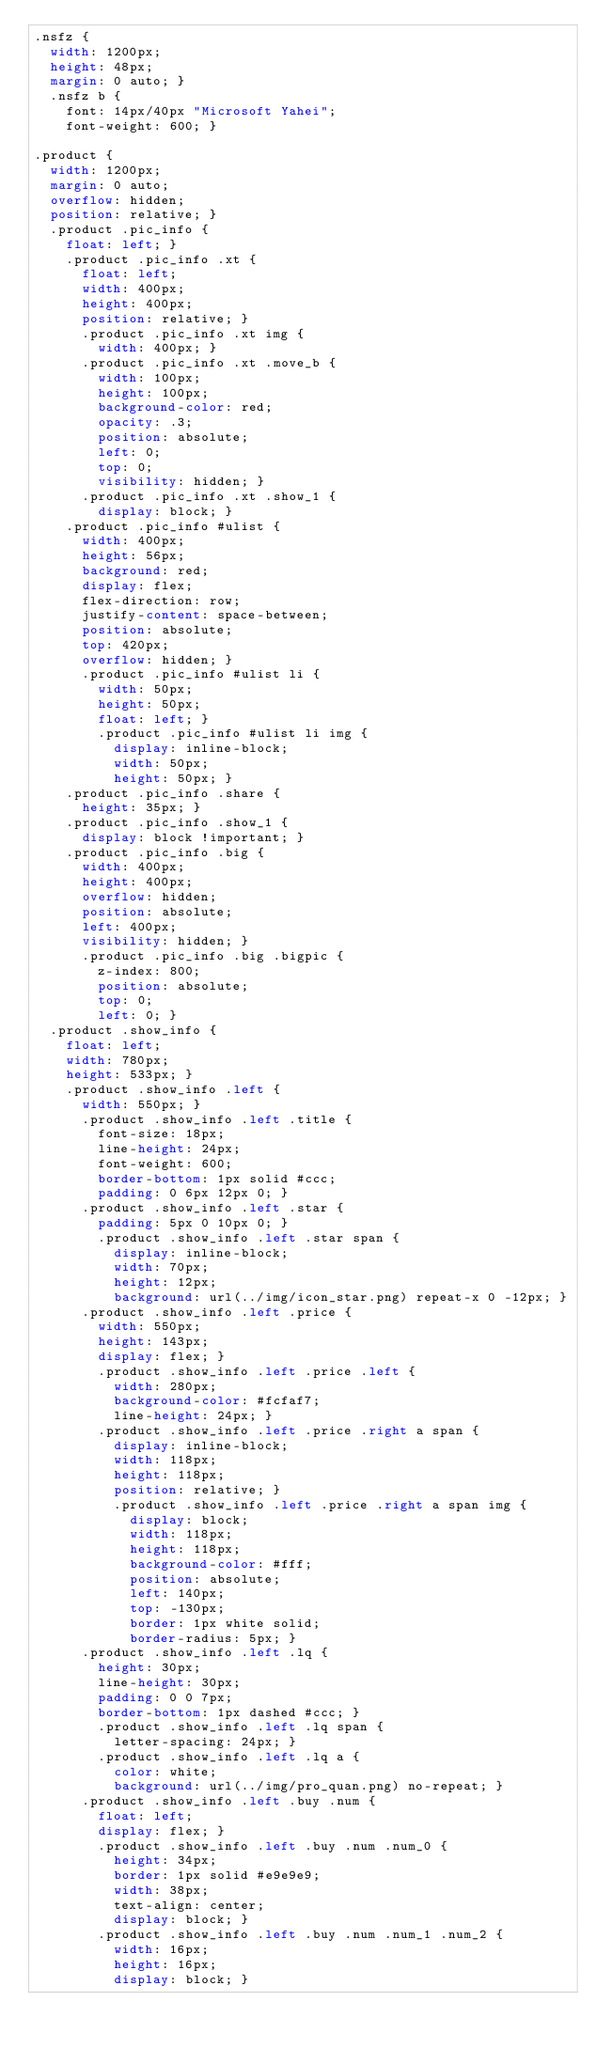Convert code to text. <code><loc_0><loc_0><loc_500><loc_500><_CSS_>.nsfz {
  width: 1200px;
  height: 48px;
  margin: 0 auto; }
  .nsfz b {
    font: 14px/40px "Microsoft Yahei";
    font-weight: 600; }

.product {
  width: 1200px;
  margin: 0 auto;
  overflow: hidden;
  position: relative; }
  .product .pic_info {
    float: left; }
    .product .pic_info .xt {
      float: left;
      width: 400px;
      height: 400px;
      position: relative; }
      .product .pic_info .xt img {
        width: 400px; }
      .product .pic_info .xt .move_b {
        width: 100px;
        height: 100px;
        background-color: red;
        opacity: .3;
        position: absolute;
        left: 0;
        top: 0;
        visibility: hidden; }
      .product .pic_info .xt .show_1 {
        display: block; }
    .product .pic_info #ulist {
      width: 400px;
      height: 56px;
      background: red;
      display: flex;
      flex-direction: row;
      justify-content: space-between;
      position: absolute;
      top: 420px;
      overflow: hidden; }
      .product .pic_info #ulist li {
        width: 50px;
        height: 50px;
        float: left; }
        .product .pic_info #ulist li img {
          display: inline-block;
          width: 50px;
          height: 50px; }
    .product .pic_info .share {
      height: 35px; }
    .product .pic_info .show_1 {
      display: block !important; }
    .product .pic_info .big {
      width: 400px;
      height: 400px;
      overflow: hidden;
      position: absolute;
      left: 400px;
      visibility: hidden; }
      .product .pic_info .big .bigpic {
        z-index: 800;
        position: absolute;
        top: 0;
        left: 0; }
  .product .show_info {
    float: left;
    width: 780px;
    height: 533px; }
    .product .show_info .left {
      width: 550px; }
      .product .show_info .left .title {
        font-size: 18px;
        line-height: 24px;
        font-weight: 600;
        border-bottom: 1px solid #ccc;
        padding: 0 6px 12px 0; }
      .product .show_info .left .star {
        padding: 5px 0 10px 0; }
        .product .show_info .left .star span {
          display: inline-block;
          width: 70px;
          height: 12px;
          background: url(../img/icon_star.png) repeat-x 0 -12px; }
      .product .show_info .left .price {
        width: 550px;
        height: 143px;
        display: flex; }
        .product .show_info .left .price .left {
          width: 280px;
          background-color: #fcfaf7;
          line-height: 24px; }
        .product .show_info .left .price .right a span {
          display: inline-block;
          width: 118px;
          height: 118px;
          position: relative; }
          .product .show_info .left .price .right a span img {
            display: block;
            width: 118px;
            height: 118px;
            background-color: #fff;
            position: absolute;
            left: 140px;
            top: -130px;
            border: 1px white solid;
            border-radius: 5px; }
      .product .show_info .left .lq {
        height: 30px;
        line-height: 30px;
        padding: 0 0 7px;
        border-bottom: 1px dashed #ccc; }
        .product .show_info .left .lq span {
          letter-spacing: 24px; }
        .product .show_info .left .lq a {
          color: white;
          background: url(../img/pro_quan.png) no-repeat; }
      .product .show_info .left .buy .num {
        float: left;
        display: flex; }
        .product .show_info .left .buy .num .num_0 {
          height: 34px;
          border: 1px solid #e9e9e9;
          width: 38px;
          text-align: center;
          display: block; }
        .product .show_info .left .buy .num .num_1 .num_2 {
          width: 16px;
          height: 16px;
          display: block; }</code> 